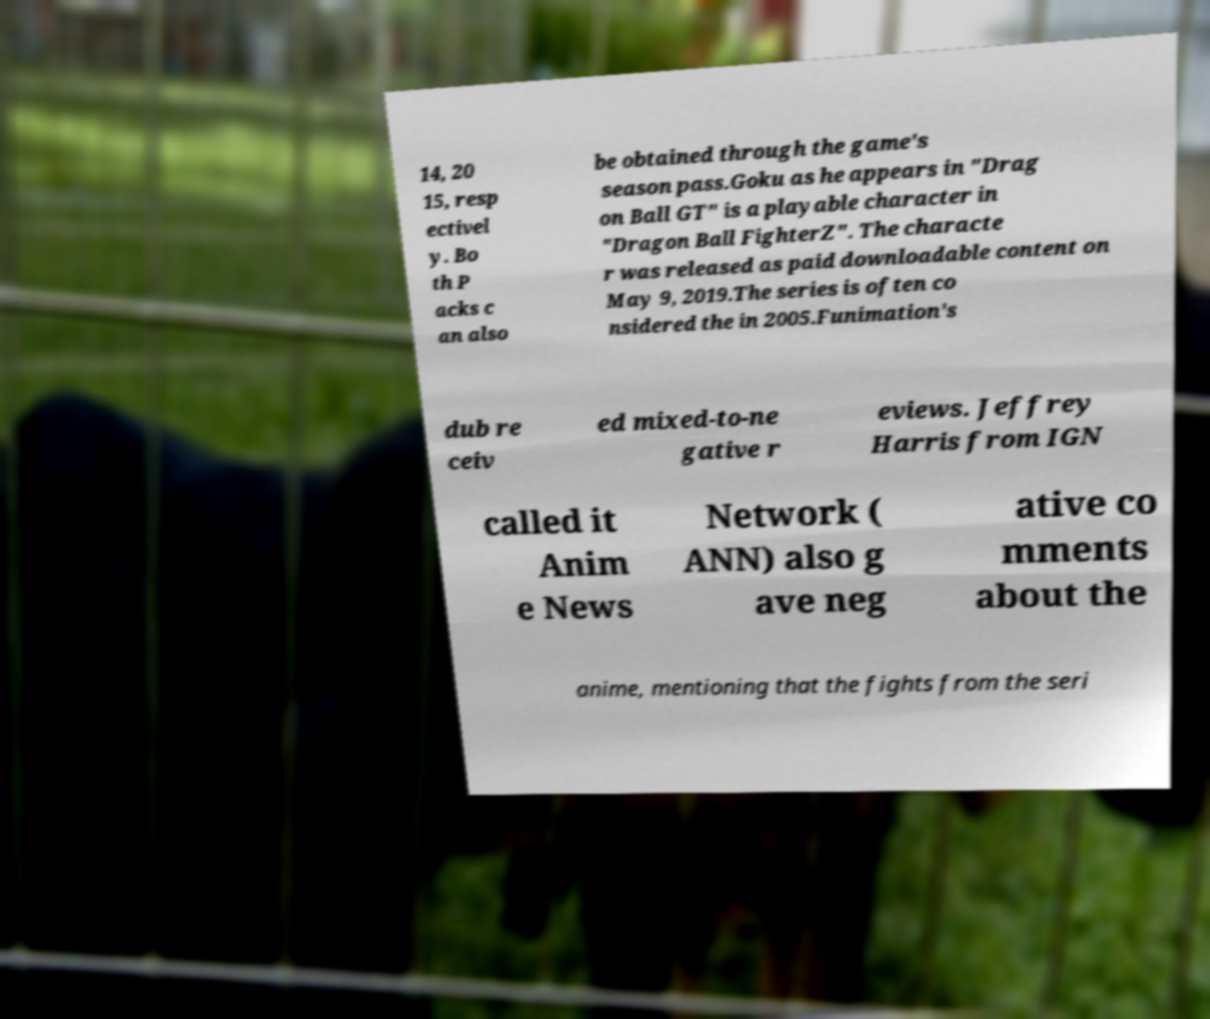Can you accurately transcribe the text from the provided image for me? 14, 20 15, resp ectivel y. Bo th P acks c an also be obtained through the game's season pass.Goku as he appears in "Drag on Ball GT" is a playable character in "Dragon Ball FighterZ". The characte r was released as paid downloadable content on May 9, 2019.The series is often co nsidered the in 2005.Funimation's dub re ceiv ed mixed-to-ne gative r eviews. Jeffrey Harris from IGN called it Anim e News Network ( ANN) also g ave neg ative co mments about the anime, mentioning that the fights from the seri 